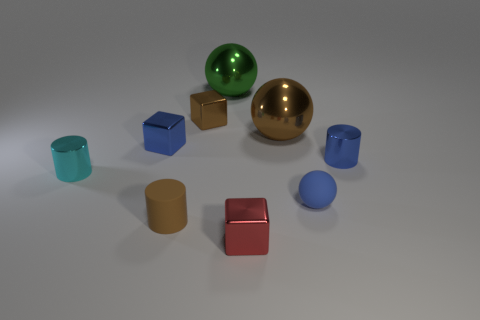There is a green metal object; what number of red cubes are behind it?
Provide a succinct answer. 0. How big is the metal thing that is both behind the large brown object and in front of the green thing?
Provide a succinct answer. Small. Are there any brown matte cylinders?
Your answer should be compact. Yes. What number of other objects are the same size as the brown ball?
Offer a very short reply. 1. Does the block that is in front of the tiny cyan cylinder have the same color as the small shiny cylinder that is on the left side of the large green metal ball?
Give a very brief answer. No. What size is the other shiny thing that is the same shape as the cyan object?
Provide a short and direct response. Small. Does the large brown ball that is behind the brown matte cylinder have the same material as the cube in front of the small ball?
Offer a very short reply. Yes. How many metal objects are either big yellow cubes or blue cylinders?
Provide a succinct answer. 1. What material is the large thing that is left of the tiny metallic cube in front of the metal cylinder on the right side of the small cyan object?
Offer a very short reply. Metal. Do the blue thing that is in front of the small cyan object and the metallic thing in front of the matte ball have the same shape?
Your answer should be compact. No. 